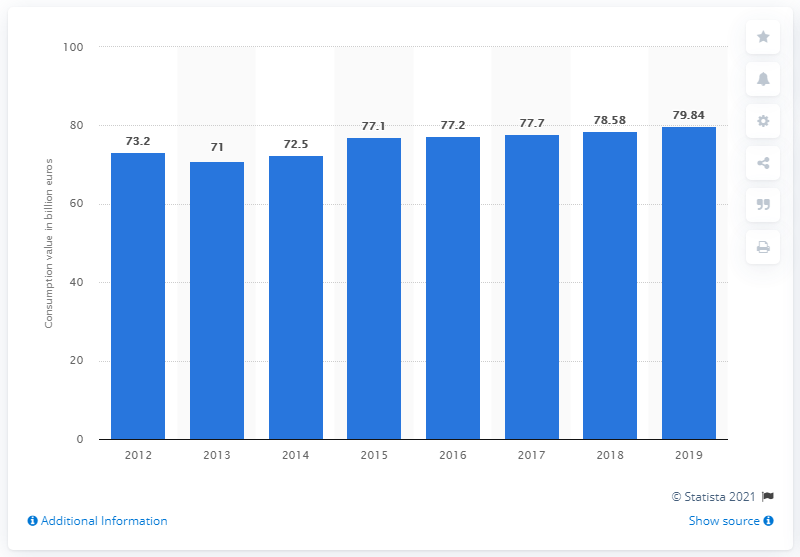Specify some key components in this picture. In 2019, the consumption value of cosmetics and personal care products was approximately 79.84. 